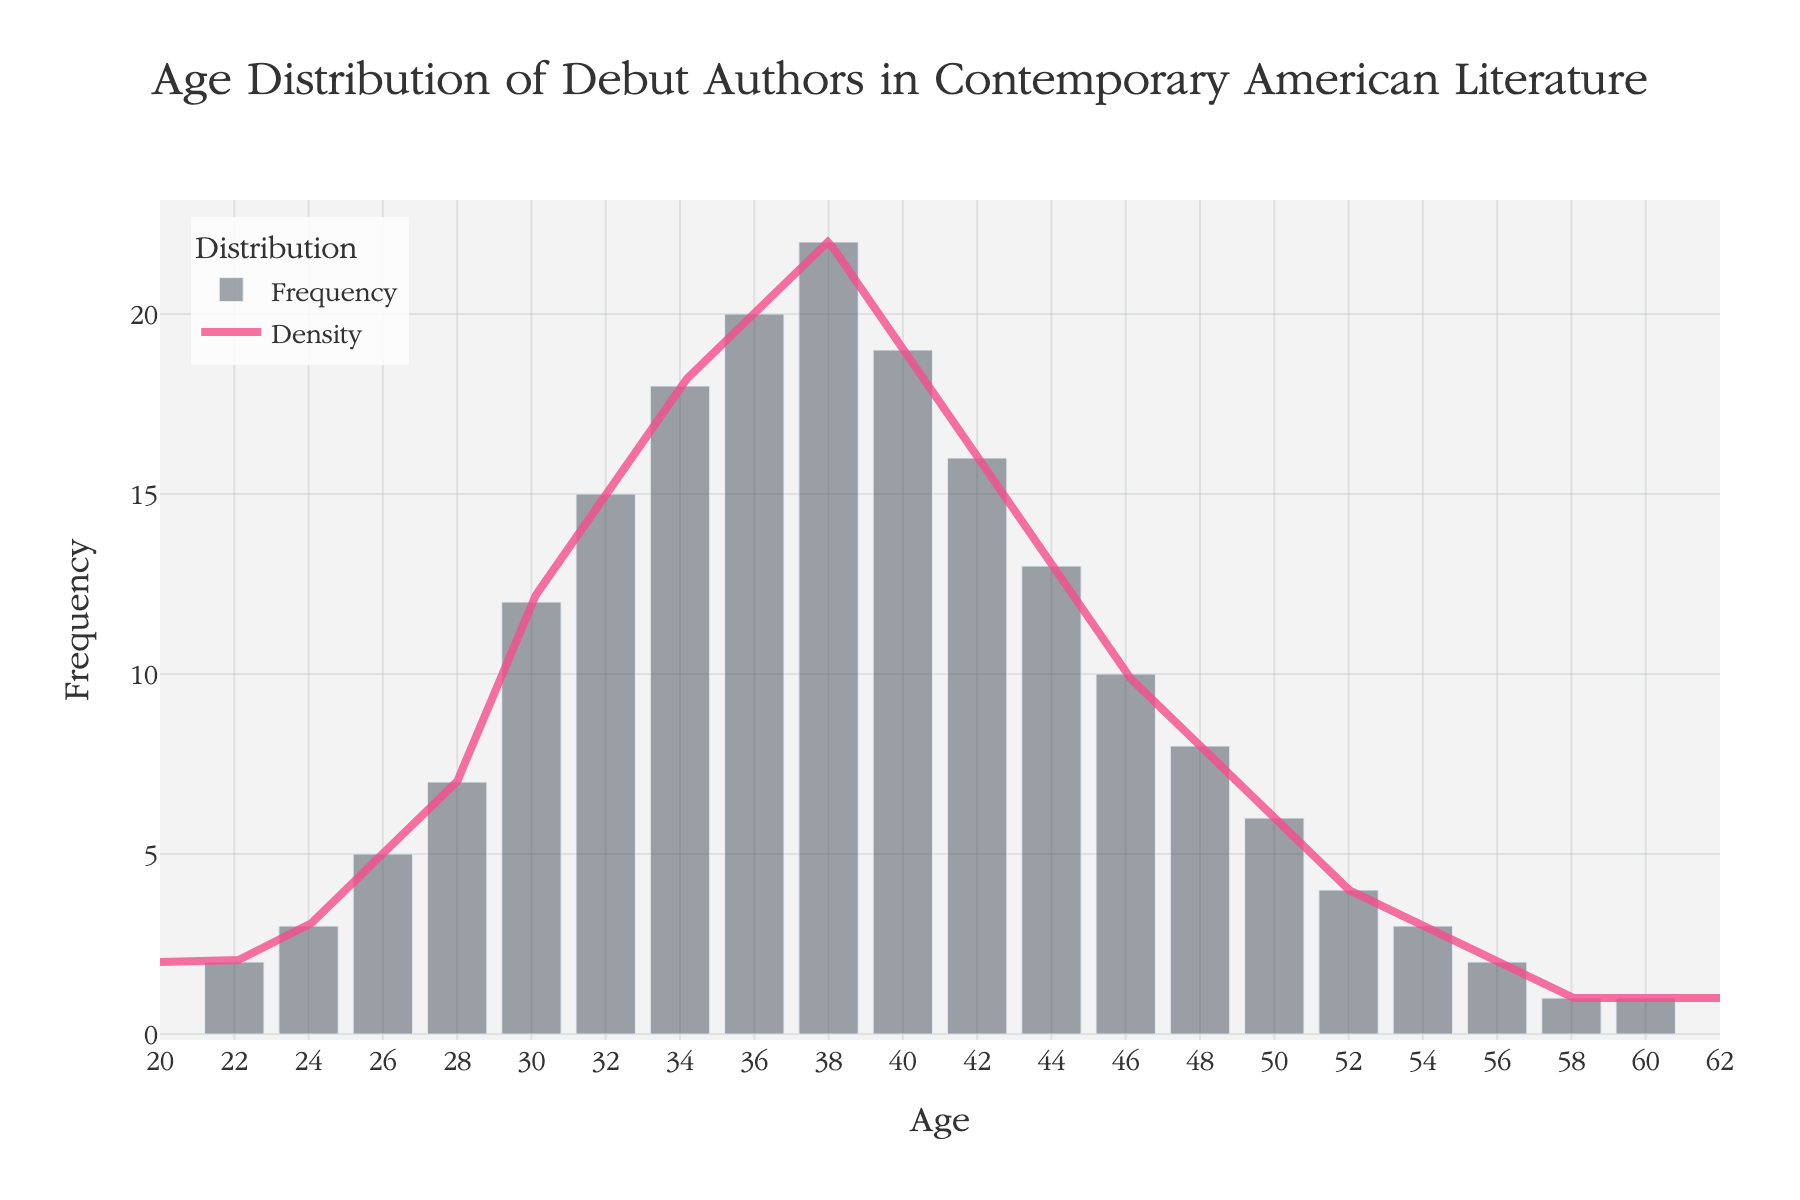What is the title of the figure? The title is displayed at the top of the figure and reads, "Age Distribution of Debut Authors in Contemporary American Literature."
Answer: Age Distribution of Debut Authors in Contemporary American Literature Which age group has the highest frequency of debut authors? By observing the height of the histogram bars, the bar corresponding to age 38 is the tallest, indicating it has the highest frequency.
Answer: 38 How many authors debuted at age 24? By looking at the bar height at age 24 on the histogram, we can see that it corresponds to a frequency of 3.
Answer: 3 What is the frequency of authors debuting at age 50 and age 60 combined? By checking the bar heights at ages 50 and 60 and summing their frequencies, we find the combined frequency is 6 (50) + 1 (60) = 7.
Answer: 7 Which age group has a higher frequency of debut authors: 30 or 44? By comparing the heights of the histogram bars at ages 30 and 44, the bar at age 30 is higher, showing a frequency of 12, while age 44 has a frequency of 13.
Answer: 44 At what age does the density curve peak? We look at the KDE curve and find the x-axis value where the curve's y-value reaches its maximum, which coincides around age 38.
Answer: 38 What can be inferred about the frequencies for ages above 50 compared to those below 50? By observing the histogram, we can see that the frequencies generally decrease after age 50, with only a few debut authors appearing in older age groups.
Answer: Decrease How does the frequency trend change from age 22 to age 30? By observing the histogram, the frequency consistently increases from age 22 to age 30. Starting from 2 (age 22) and rising to 12 (age 30).
Answer: Increasing What is the frequency difference between the youngest and oldest debut authors? The frequency of the youngest (age 22) is 2, and the oldest (age 60) is 1. The difference is 2 - 1 = 1.
Answer: 1 Is the distribution of debut authors' ages symmetrical around the peak? By observing the histogram and KDE curve around the peak (age 38), it appears that the distribution is somewhat symmetrical, with frequencies decreasing on both sides of the peak but not perfectly mirrored.
Answer: Somewhat symmetrical 